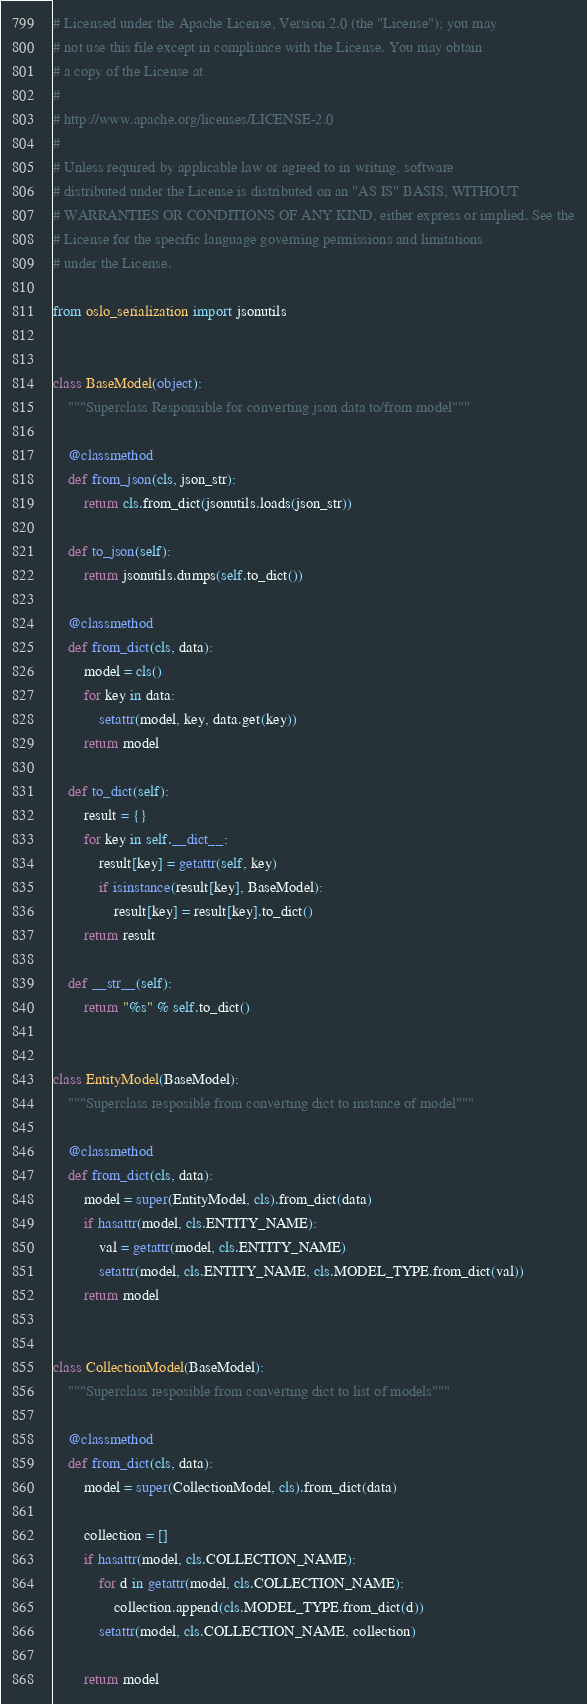<code> <loc_0><loc_0><loc_500><loc_500><_Python_># Licensed under the Apache License, Version 2.0 (the "License"); you may
# not use this file except in compliance with the License. You may obtain
# a copy of the License at
#
# http://www.apache.org/licenses/LICENSE-2.0
#
# Unless required by applicable law or agreed to in writing, software
# distributed under the License is distributed on an "AS IS" BASIS, WITHOUT
# WARRANTIES OR CONDITIONS OF ANY KIND, either express or implied. See the
# License for the specific language governing permissions and limitations
# under the License.

from oslo_serialization import jsonutils


class BaseModel(object):
    """Superclass Responsible for converting json data to/from model"""

    @classmethod
    def from_json(cls, json_str):
        return cls.from_dict(jsonutils.loads(json_str))

    def to_json(self):
        return jsonutils.dumps(self.to_dict())

    @classmethod
    def from_dict(cls, data):
        model = cls()
        for key in data:
            setattr(model, key, data.get(key))
        return model

    def to_dict(self):
        result = {}
        for key in self.__dict__:
            result[key] = getattr(self, key)
            if isinstance(result[key], BaseModel):
                result[key] = result[key].to_dict()
        return result

    def __str__(self):
        return "%s" % self.to_dict()


class EntityModel(BaseModel):
    """Superclass resposible from converting dict to instance of model"""

    @classmethod
    def from_dict(cls, data):
        model = super(EntityModel, cls).from_dict(data)
        if hasattr(model, cls.ENTITY_NAME):
            val = getattr(model, cls.ENTITY_NAME)
            setattr(model, cls.ENTITY_NAME, cls.MODEL_TYPE.from_dict(val))
        return model


class CollectionModel(BaseModel):
    """Superclass resposible from converting dict to list of models"""

    @classmethod
    def from_dict(cls, data):
        model = super(CollectionModel, cls).from_dict(data)

        collection = []
        if hasattr(model, cls.COLLECTION_NAME):
            for d in getattr(model, cls.COLLECTION_NAME):
                collection.append(cls.MODEL_TYPE.from_dict(d))
            setattr(model, cls.COLLECTION_NAME, collection)

        return model
</code> 